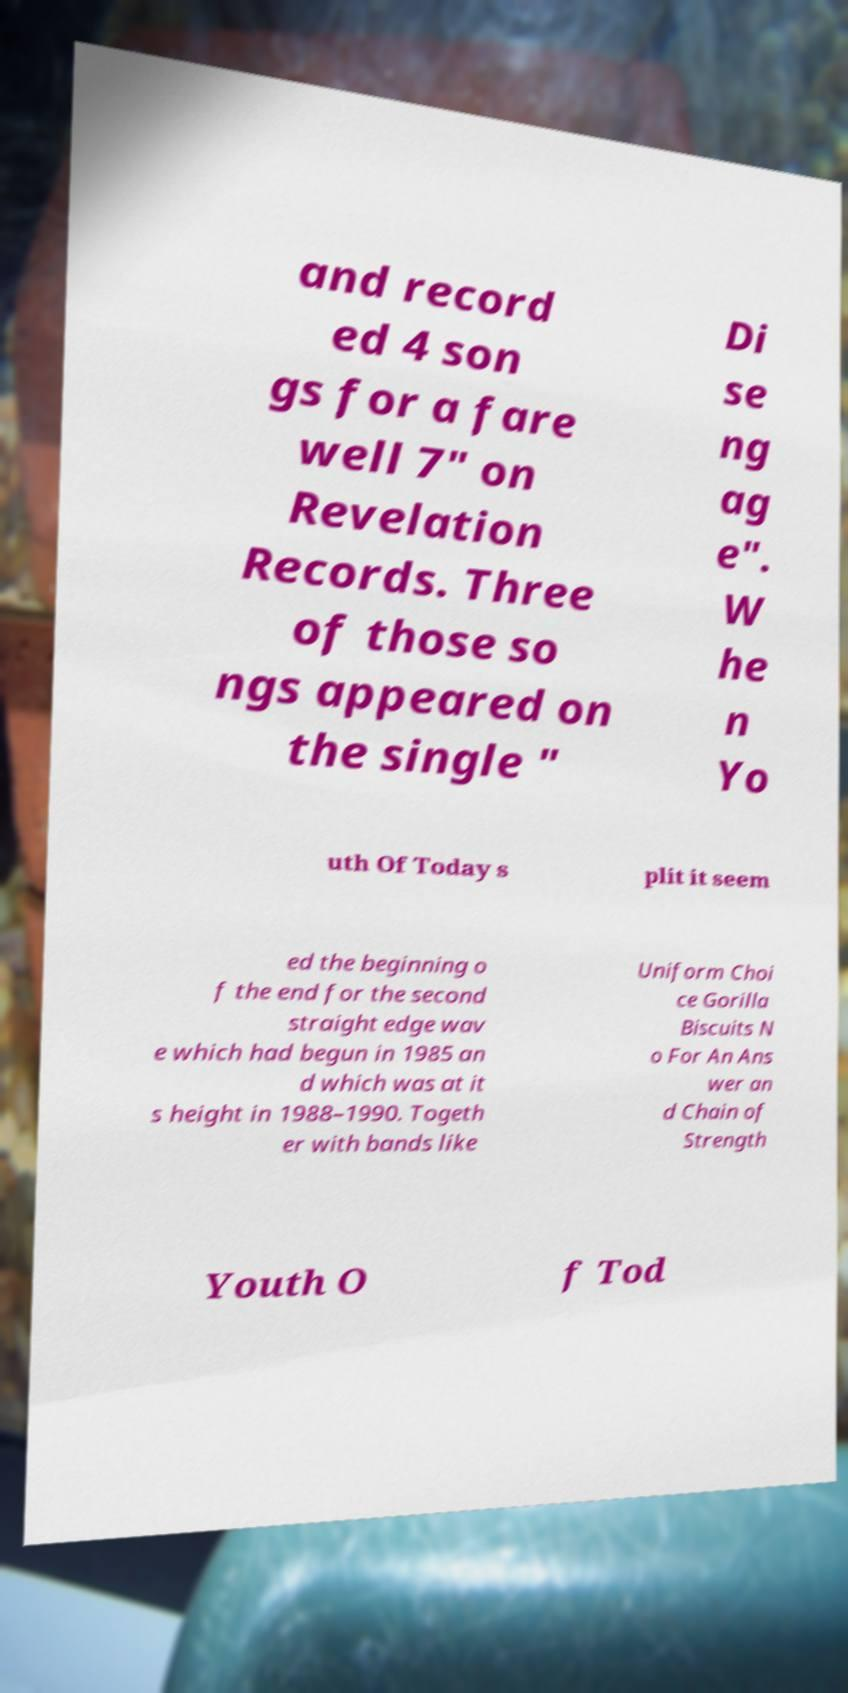Can you accurately transcribe the text from the provided image for me? and record ed 4 son gs for a fare well 7" on Revelation Records. Three of those so ngs appeared on the single " Di se ng ag e". W he n Yo uth Of Today s plit it seem ed the beginning o f the end for the second straight edge wav e which had begun in 1985 an d which was at it s height in 1988–1990. Togeth er with bands like Uniform Choi ce Gorilla Biscuits N o For An Ans wer an d Chain of Strength Youth O f Tod 